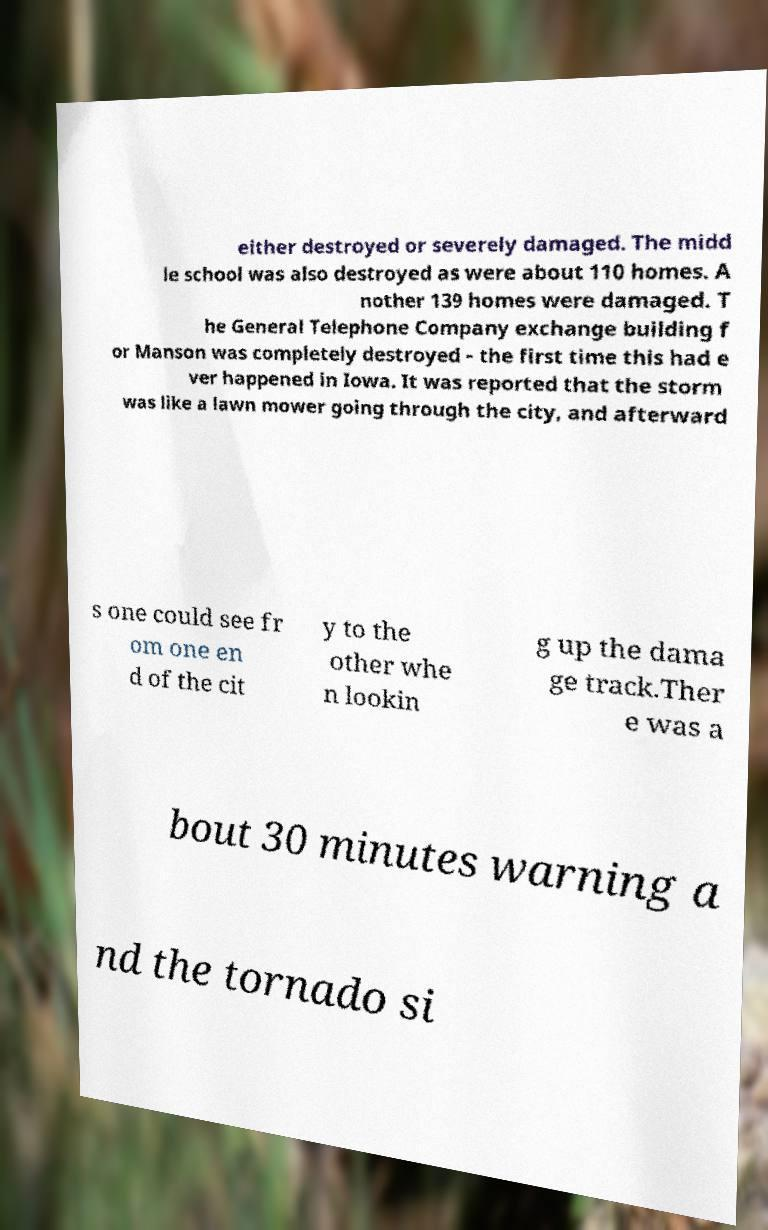Could you assist in decoding the text presented in this image and type it out clearly? either destroyed or severely damaged. The midd le school was also destroyed as were about 110 homes. A nother 139 homes were damaged. T he General Telephone Company exchange building f or Manson was completely destroyed - the first time this had e ver happened in Iowa. It was reported that the storm was like a lawn mower going through the city, and afterward s one could see fr om one en d of the cit y to the other whe n lookin g up the dama ge track.Ther e was a bout 30 minutes warning a nd the tornado si 